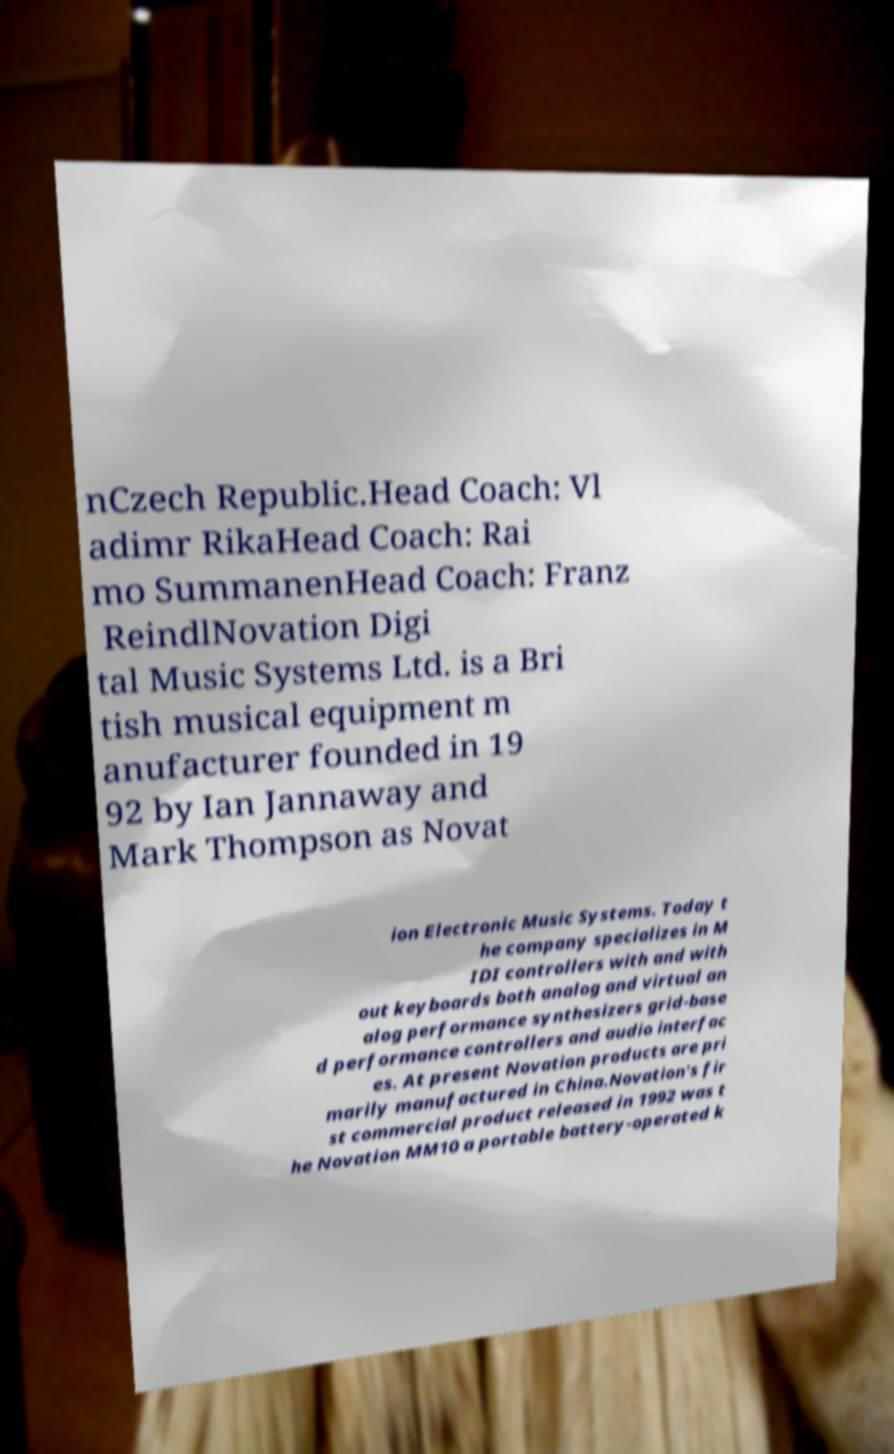For documentation purposes, I need the text within this image transcribed. Could you provide that? nCzech Republic.Head Coach: Vl adimr RikaHead Coach: Rai mo SummanenHead Coach: Franz ReindlNovation Digi tal Music Systems Ltd. is a Bri tish musical equipment m anufacturer founded in 19 92 by Ian Jannaway and Mark Thompson as Novat ion Electronic Music Systems. Today t he company specializes in M IDI controllers with and with out keyboards both analog and virtual an alog performance synthesizers grid-base d performance controllers and audio interfac es. At present Novation products are pri marily manufactured in China.Novation's fir st commercial product released in 1992 was t he Novation MM10 a portable battery-operated k 